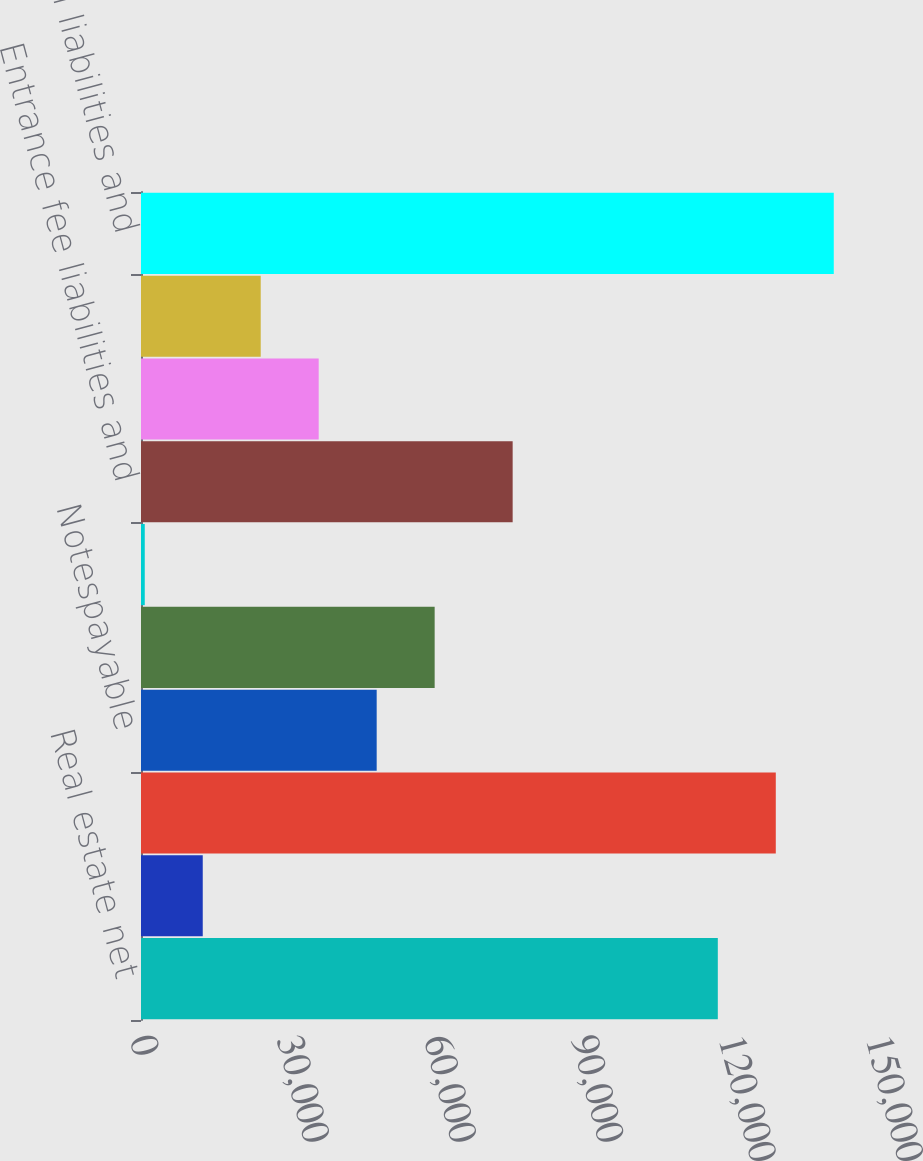Convert chart. <chart><loc_0><loc_0><loc_500><loc_500><bar_chart><fcel>Real estate net<fcel>Other assets<fcel>Total assets<fcel>Notespayable<fcel>Mortgagenotespayable<fcel>Accounts payable<fcel>Entrance fee liabilities and<fcel>Other partners' capital<fcel>HCP's capital<fcel>Total liabilities and<nl><fcel>117557<fcel>12583.6<fcel>129374<fcel>48033.4<fcel>59850<fcel>767<fcel>75746<fcel>36216.8<fcel>24400.2<fcel>141190<nl></chart> 